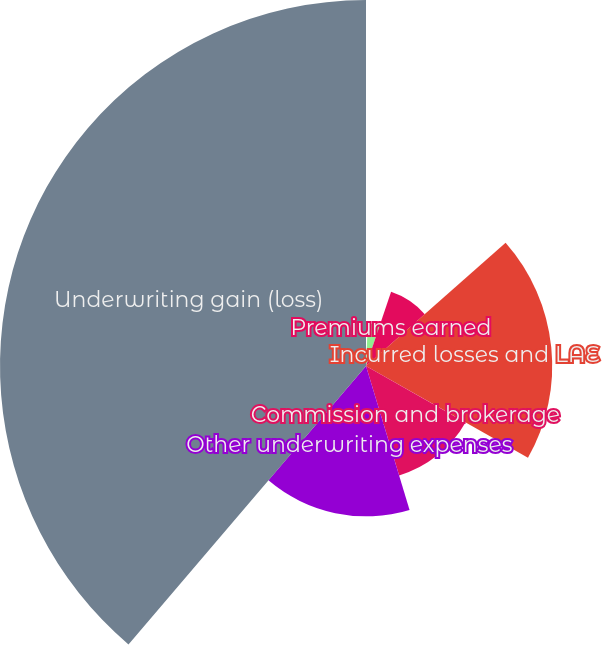Convert chart to OTSL. <chart><loc_0><loc_0><loc_500><loc_500><pie_chart><fcel>Gross written premiums<fcel>Net written premiums<fcel>Premiums earned<fcel>Incurred losses and LAE<fcel>Commission and brokerage<fcel>Other underwriting expenses<fcel>Underwriting gain (loss)<nl><fcel>0.69%<fcel>4.5%<fcel>8.3%<fcel>19.72%<fcel>12.11%<fcel>15.92%<fcel>38.76%<nl></chart> 